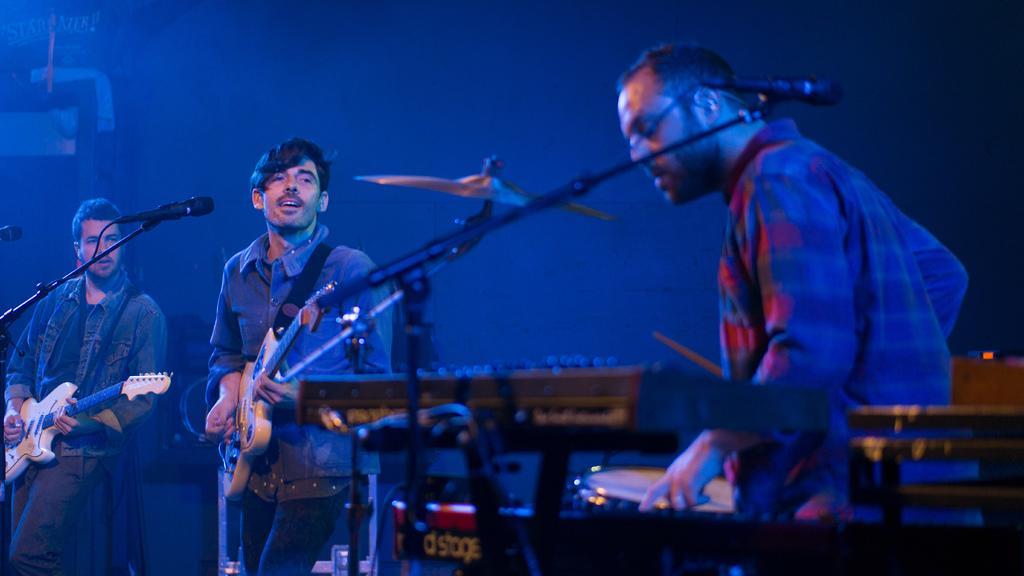In one or two sentences, can you explain what this image depicts? This 3 persons are highlighted in this picture. This 2 persons hold guitars. In-front of this person there is a mic and holder. This person plays a musical instruments. 